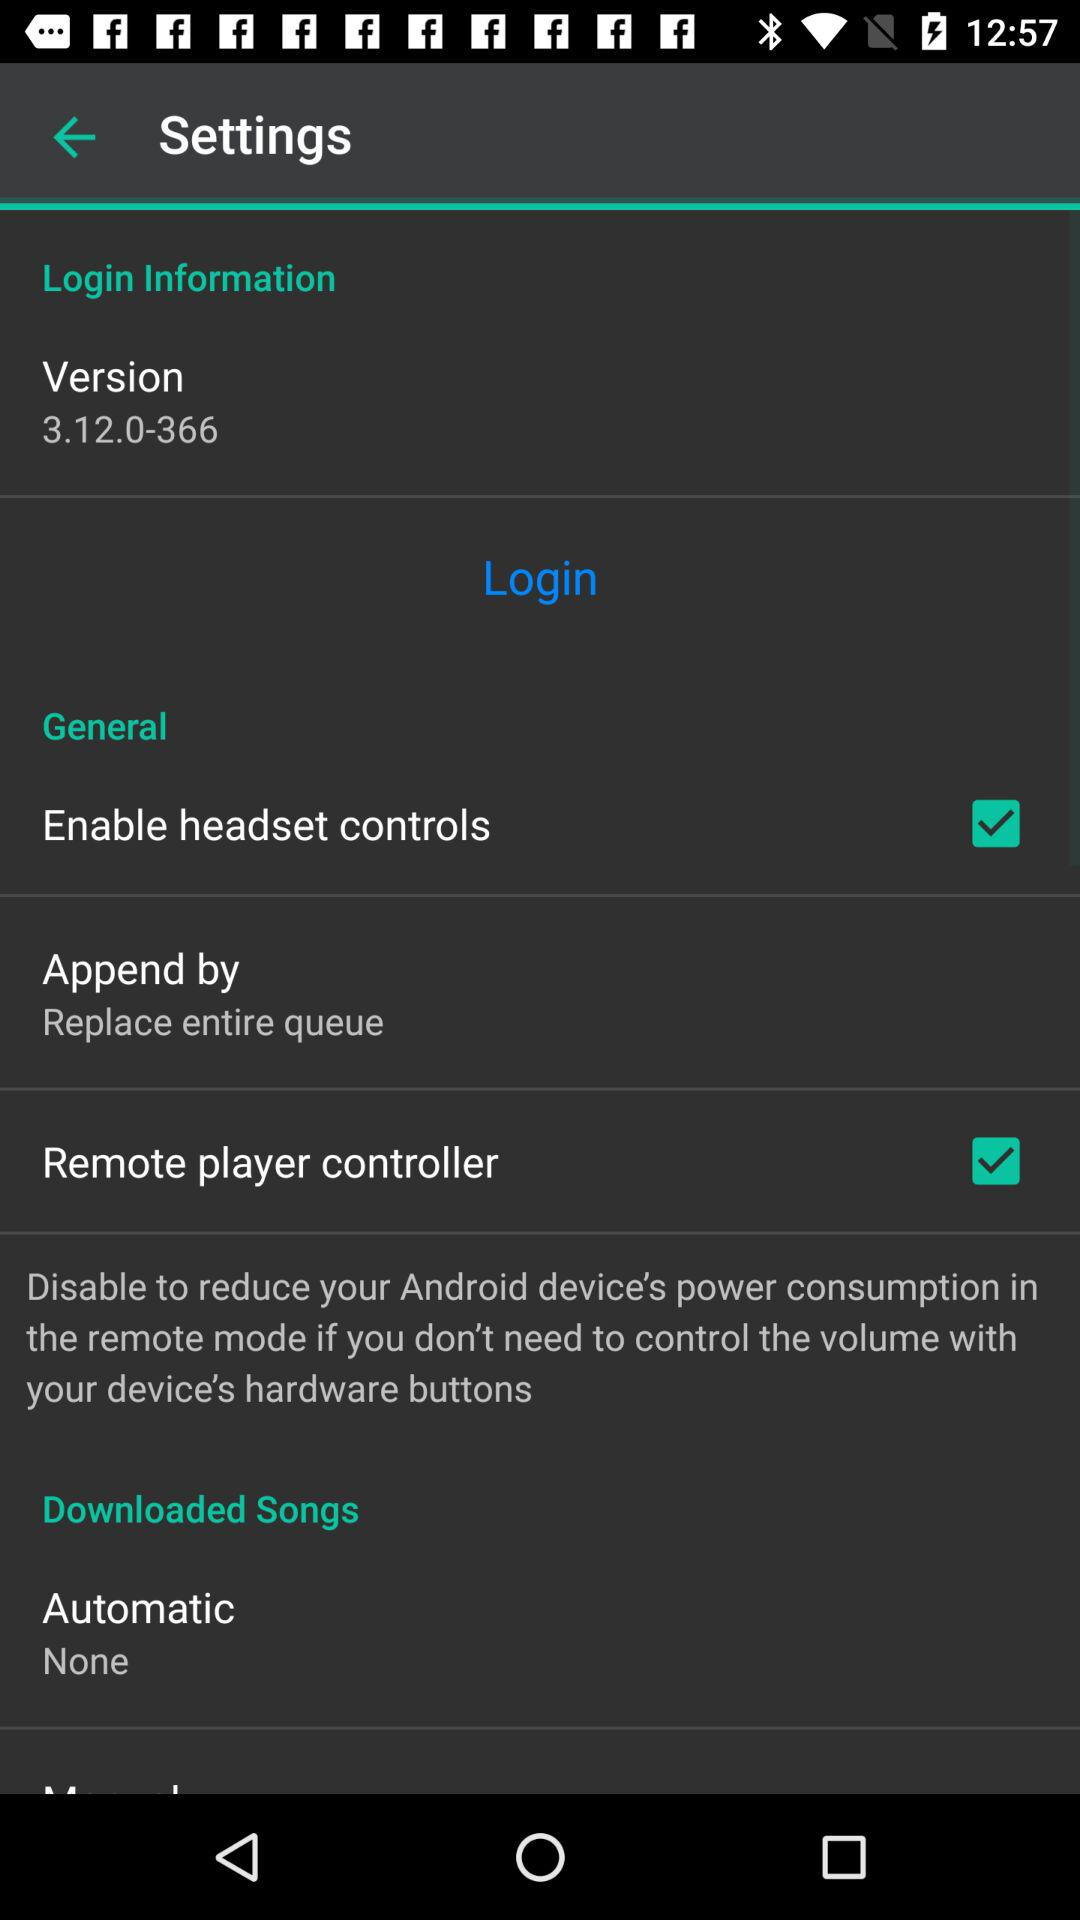What is the version? The version is 3.12.0-366. 